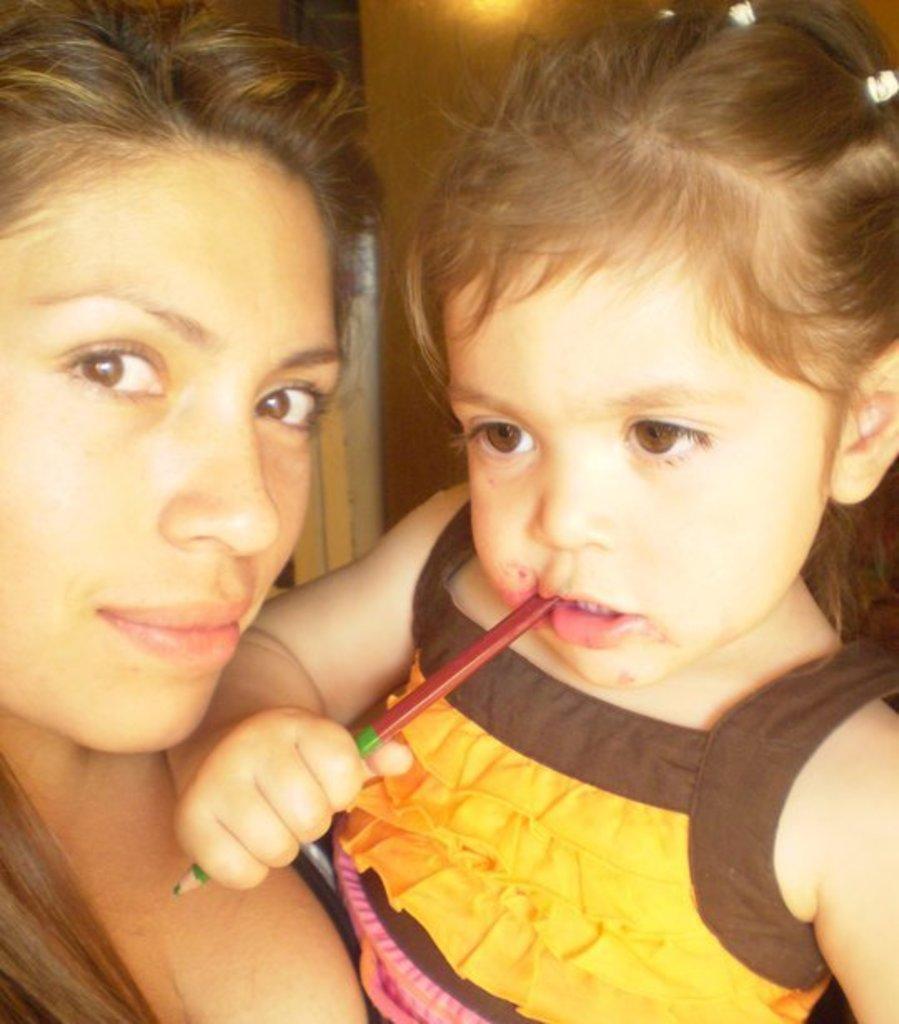Please provide a concise description of this image. In this picture we can see a woman standing in the front and holding the small girl in her hand, smiling and giving a pose to the camera. 